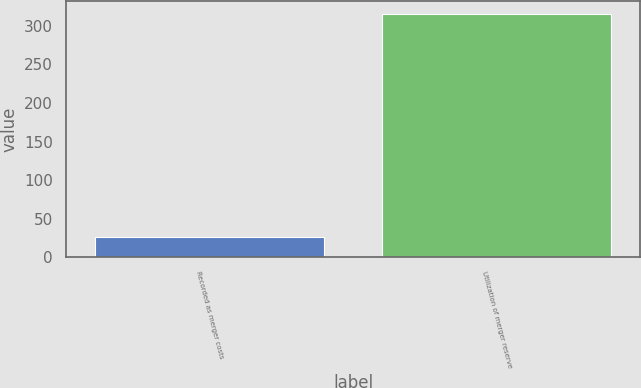Convert chart. <chart><loc_0><loc_0><loc_500><loc_500><bar_chart><fcel>Recorded as merger costs<fcel>Utilization of merger reserve<nl><fcel>26<fcel>316<nl></chart> 